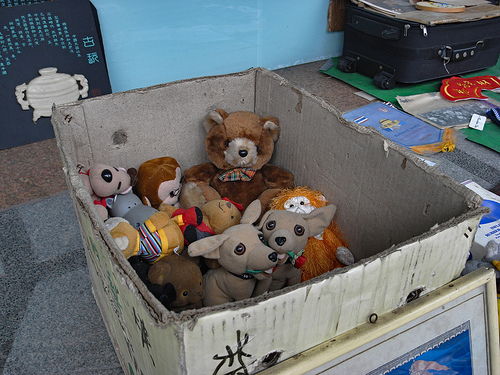<image>
Can you confirm if the toy is behind the box? No. The toy is not behind the box. From this viewpoint, the toy appears to be positioned elsewhere in the scene. 